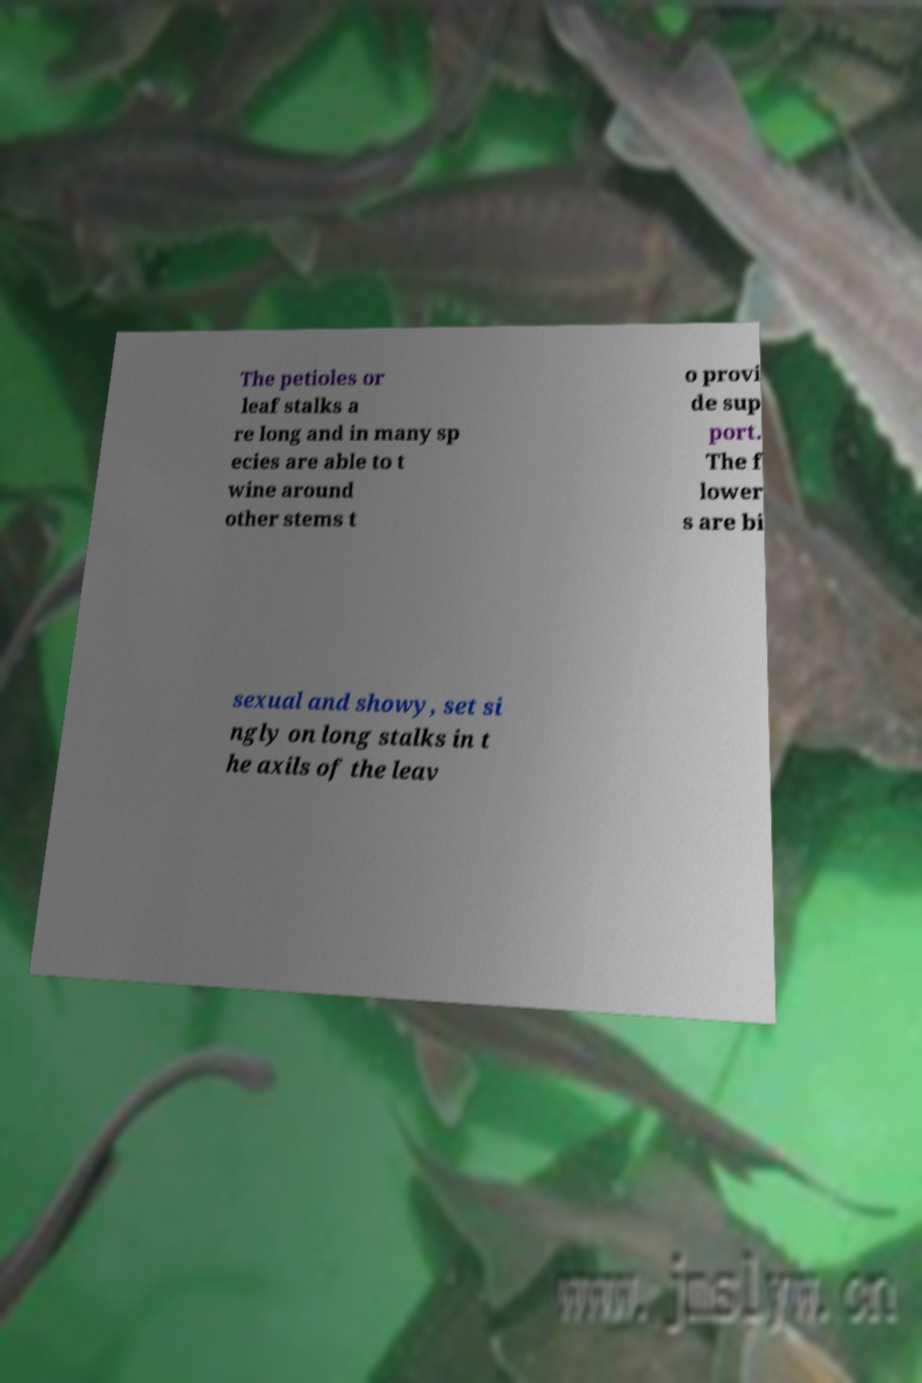Could you extract and type out the text from this image? The petioles or leaf stalks a re long and in many sp ecies are able to t wine around other stems t o provi de sup port. The f lower s are bi sexual and showy, set si ngly on long stalks in t he axils of the leav 